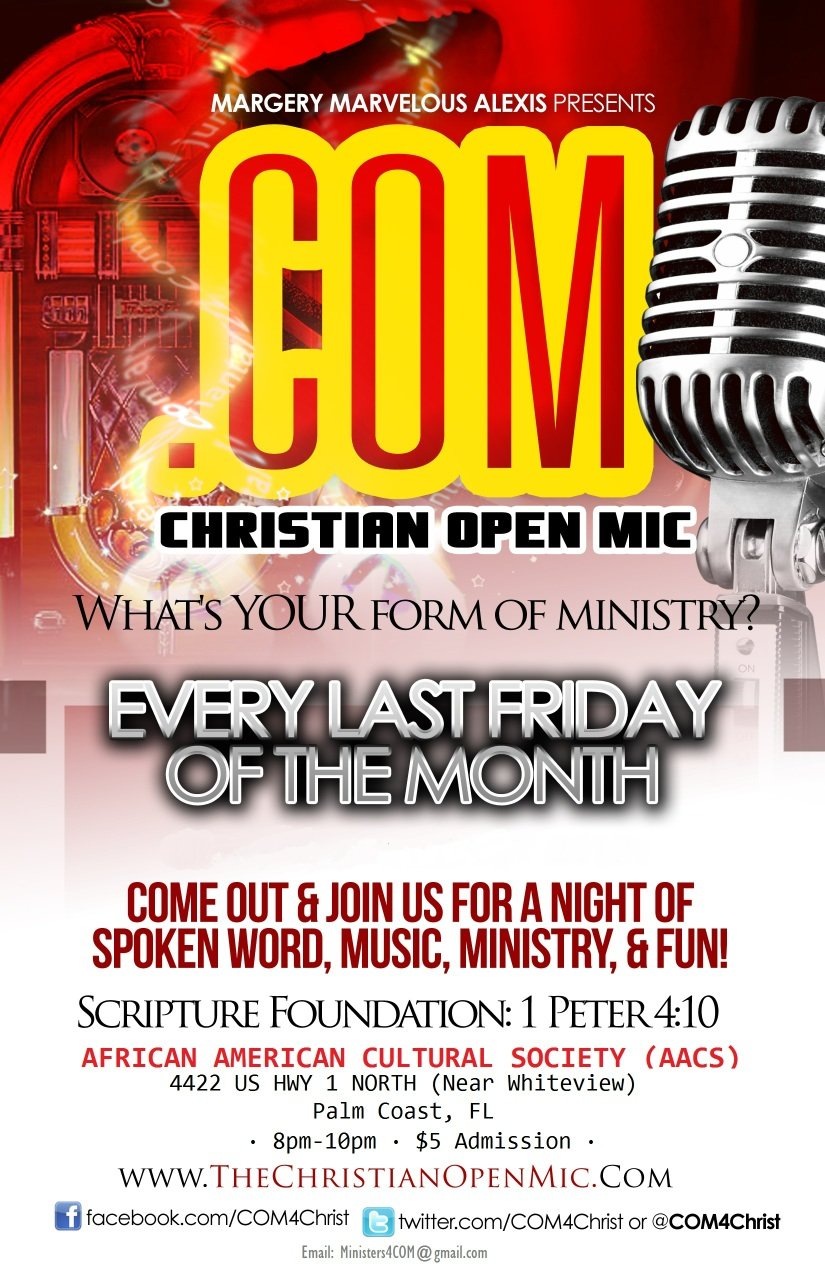Realistically, what kind of crowd typically attends the Christian Open Mic events? The Christian Open Mic events typically draw a diverse crowd, including local community members, families, students, and individuals of all ages who share an interest in faith-based artistic expression. The events are designed to be welcoming and inclusive, encouraging participation and fellowship among attendees. 